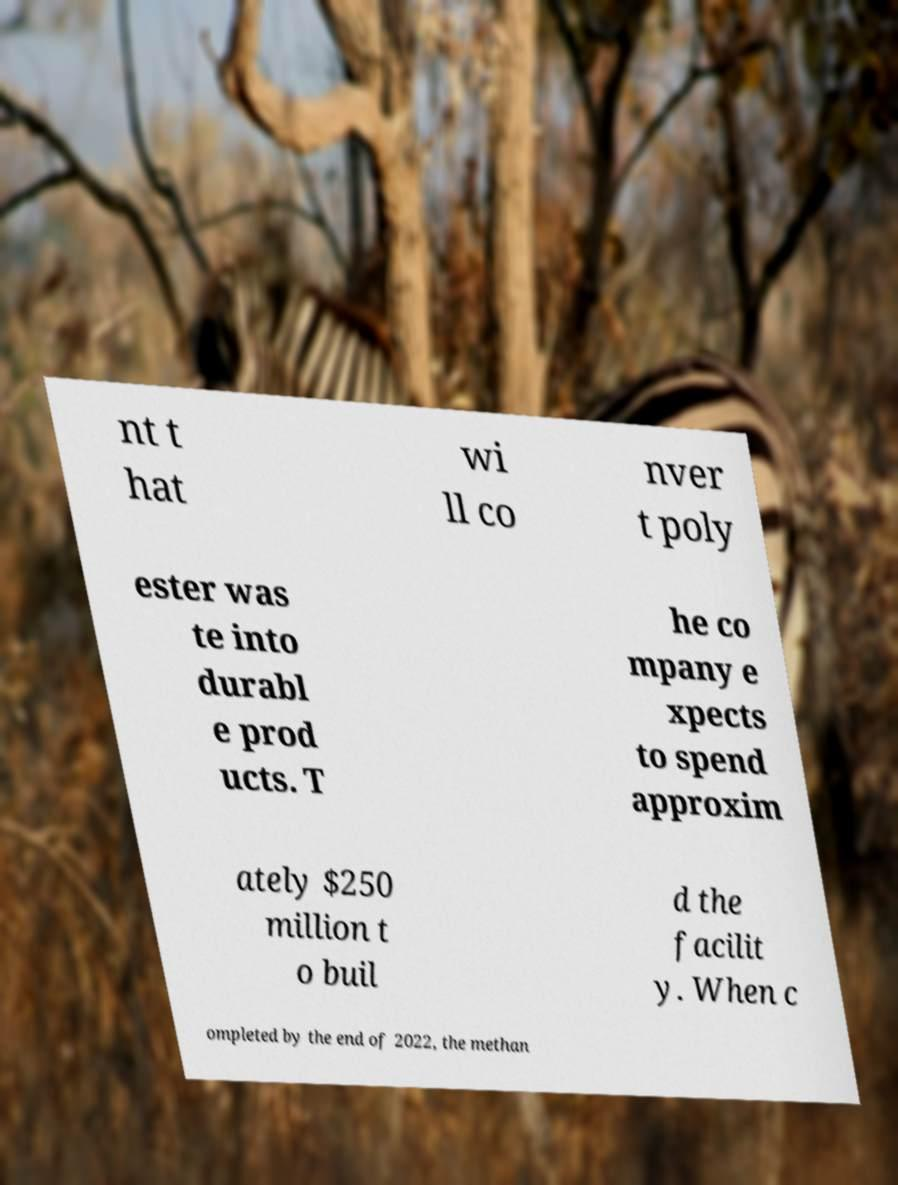Could you assist in decoding the text presented in this image and type it out clearly? nt t hat wi ll co nver t poly ester was te into durabl e prod ucts. T he co mpany e xpects to spend approxim ately $250 million t o buil d the facilit y. When c ompleted by the end of 2022, the methan 